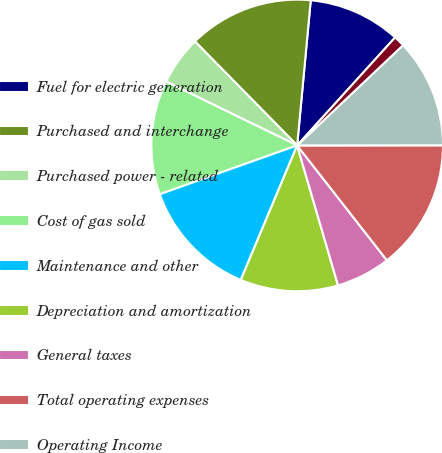Convert chart. <chart><loc_0><loc_0><loc_500><loc_500><pie_chart><fcel>Fuel for electric generation<fcel>Purchased and interchange<fcel>Purchased power - related<fcel>Cost of gas sold<fcel>Maintenance and other<fcel>Depreciation and amortization<fcel>General taxes<fcel>Total operating expenses<fcel>Operating Income<fcel>Interest income<nl><fcel>10.24%<fcel>13.85%<fcel>5.42%<fcel>12.65%<fcel>13.25%<fcel>10.84%<fcel>6.03%<fcel>14.46%<fcel>12.05%<fcel>1.21%<nl></chart> 